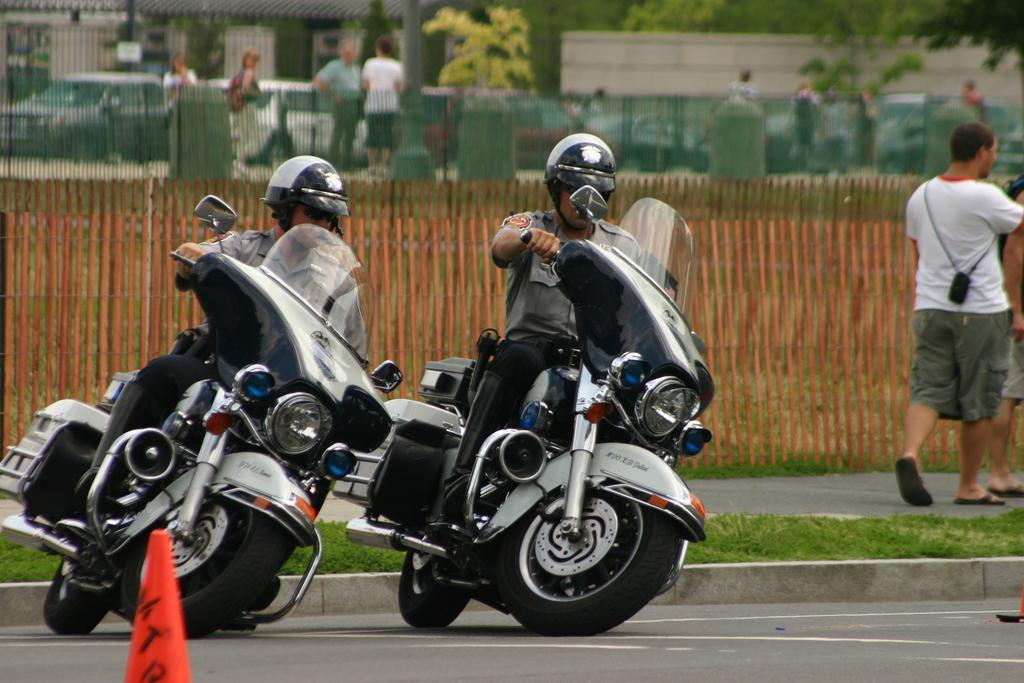What are the two men in the image doing? The two men are riding a bike in the image. What is happening on the right side of the image? There is a man walking on the right side of the image. What can be seen in the background of the image? There are people standing and a tree visible in the background of the image. What architectural feature is present in the background of the image? There is a wall in the background of the image. Can you hear the whistle of the range in the image? There is no whistle or range present in the image; it features two men riding a bike, a man walking, people standing, a tree, and a wall in the background. Is there a beggar visible in the image? There is no beggar present in the image. 